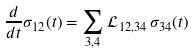Convert formula to latex. <formula><loc_0><loc_0><loc_500><loc_500>\frac { d } { d t } \sigma _ { 1 2 } ( t ) = \sum _ { 3 , 4 } \mathcal { L } _ { 1 2 , 3 4 } \, \sigma _ { 3 4 } ( t )</formula> 